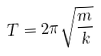<formula> <loc_0><loc_0><loc_500><loc_500>T = 2 \pi \sqrt { \frac { m } { k } }</formula> 